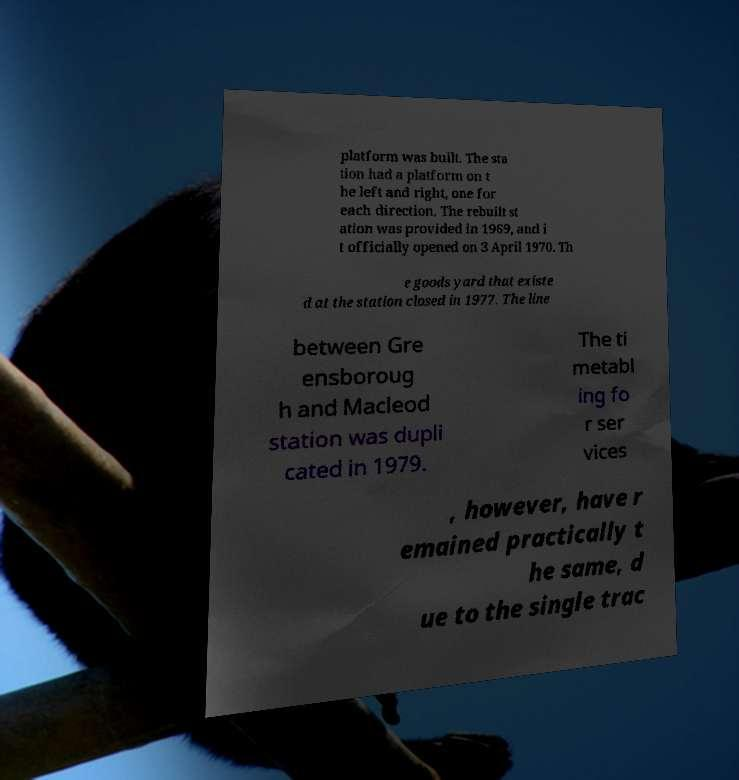What messages or text are displayed in this image? I need them in a readable, typed format. platform was built. The sta tion had a platform on t he left and right, one for each direction. The rebuilt st ation was provided in 1969, and i t officially opened on 3 April 1970. Th e goods yard that existe d at the station closed in 1977. The line between Gre ensboroug h and Macleod station was dupli cated in 1979. The ti metabl ing fo r ser vices , however, have r emained practically t he same, d ue to the single trac 